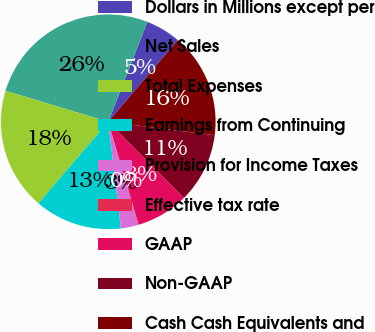Convert chart to OTSL. <chart><loc_0><loc_0><loc_500><loc_500><pie_chart><fcel>Dollars in Millions except per<fcel>Net Sales<fcel>Total Expenses<fcel>Earnings from Continuing<fcel>Provision for Income Taxes<fcel>Effective tax rate<fcel>GAAP<fcel>Non-GAAP<fcel>Cash Cash Equivalents and<nl><fcel>5.28%<fcel>26.27%<fcel>18.4%<fcel>13.15%<fcel>2.66%<fcel>0.03%<fcel>7.9%<fcel>10.53%<fcel>15.77%<nl></chart> 